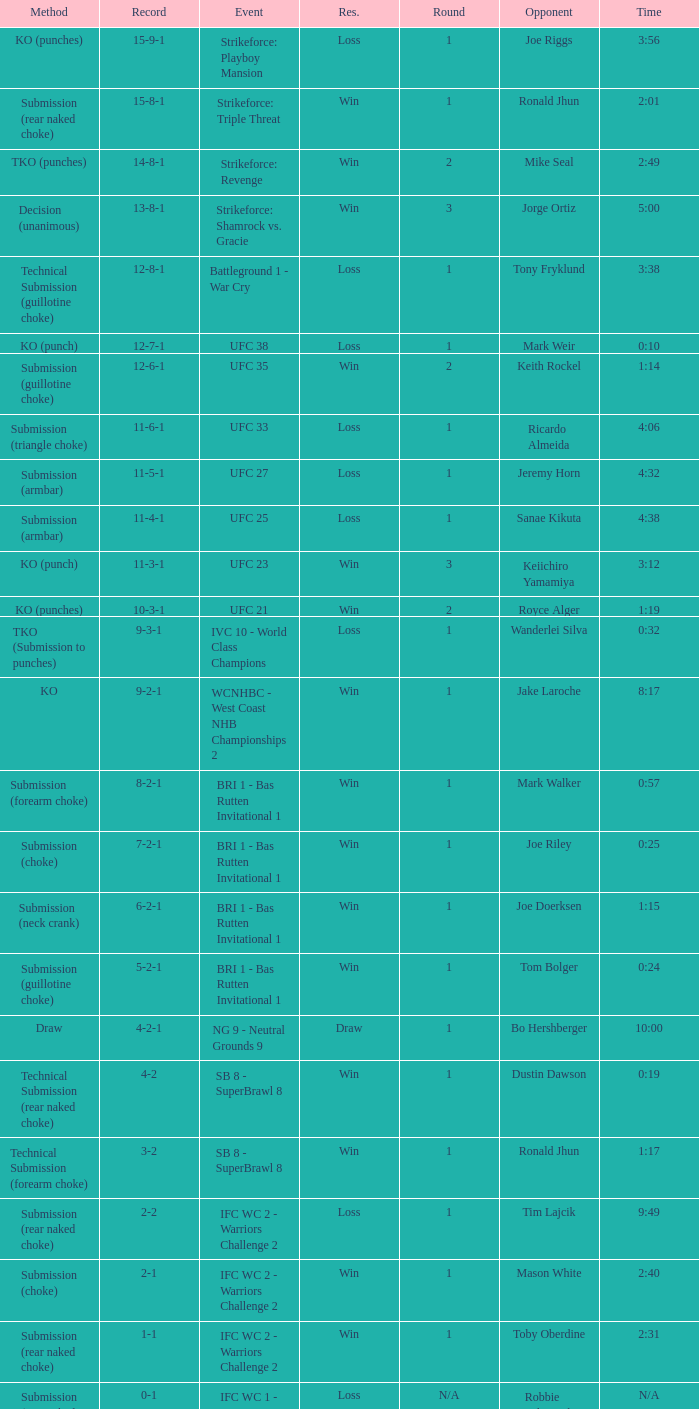What was the record when the method of resolution was KO? 9-2-1. 